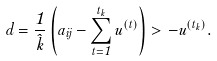<formula> <loc_0><loc_0><loc_500><loc_500>d = \frac { 1 } { \hat { k } } \left ( a _ { i j } - \sum _ { t = 1 } ^ { t _ { k } } u ^ { ( t ) } \right ) > - u ^ { ( t _ { k } ) } .</formula> 